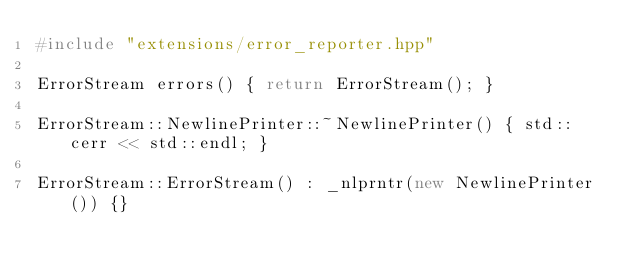<code> <loc_0><loc_0><loc_500><loc_500><_C++_>#include "extensions/error_reporter.hpp"

ErrorStream errors() { return ErrorStream(); }

ErrorStream::NewlinePrinter::~NewlinePrinter() { std::cerr << std::endl; }

ErrorStream::ErrorStream() : _nlprntr(new NewlinePrinter()) {}
</code> 